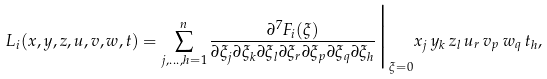Convert formula to latex. <formula><loc_0><loc_0><loc_500><loc_500>L _ { i } ( { x } , { y } , { z } , { u } , { v } , { w } , { t } ) = \sum _ { j , \dots , h = 1 } ^ { n } \frac { \partial ^ { 7 } F _ { i } ( \xi ) } { \partial \xi _ { j } \partial \xi _ { k } \partial \xi _ { l } \partial \xi _ { r } \partial \xi _ { p } \partial \xi _ { q } \partial \xi _ { h } } \Big | _ { \xi = 0 } x _ { j } \, y _ { k } \, z _ { l } \, u _ { r } \, v _ { p } \, w _ { q } \, t _ { h } ,</formula> 